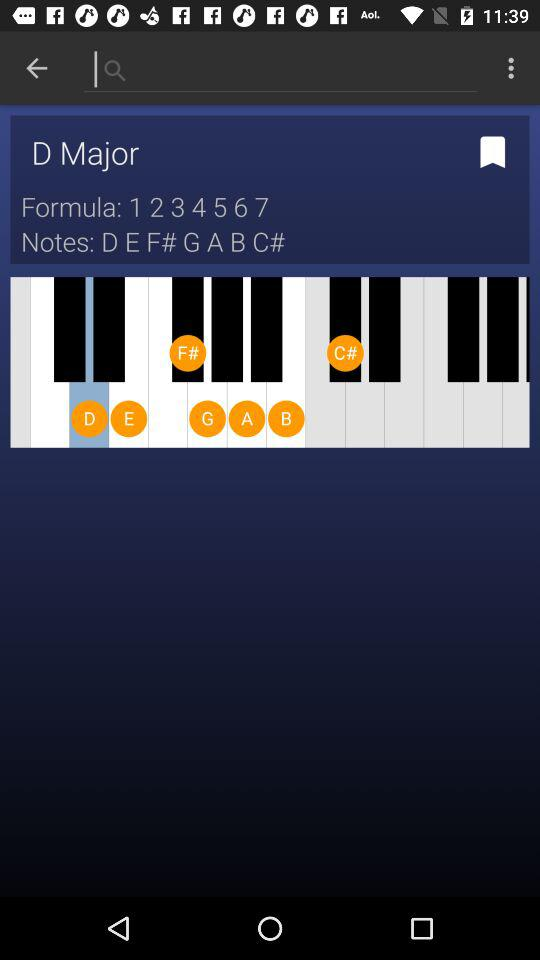What exactly are the user's notes? The user's notes are "D E F# G A B C#". 